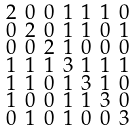Convert formula to latex. <formula><loc_0><loc_0><loc_500><loc_500>\begin{smallmatrix} 2 & 0 & 0 & 1 & 1 & 1 & 0 \\ 0 & 2 & 0 & 1 & 1 & 0 & 1 \\ 0 & 0 & 2 & 1 & 0 & 0 & 0 \\ 1 & 1 & 1 & 3 & 1 & 1 & 1 \\ 1 & 1 & 0 & 1 & 3 & 1 & 0 \\ 1 & 0 & 0 & 1 & 1 & 3 & 0 \\ 0 & 1 & 0 & 1 & 0 & 0 & 3 \end{smallmatrix}</formula> 